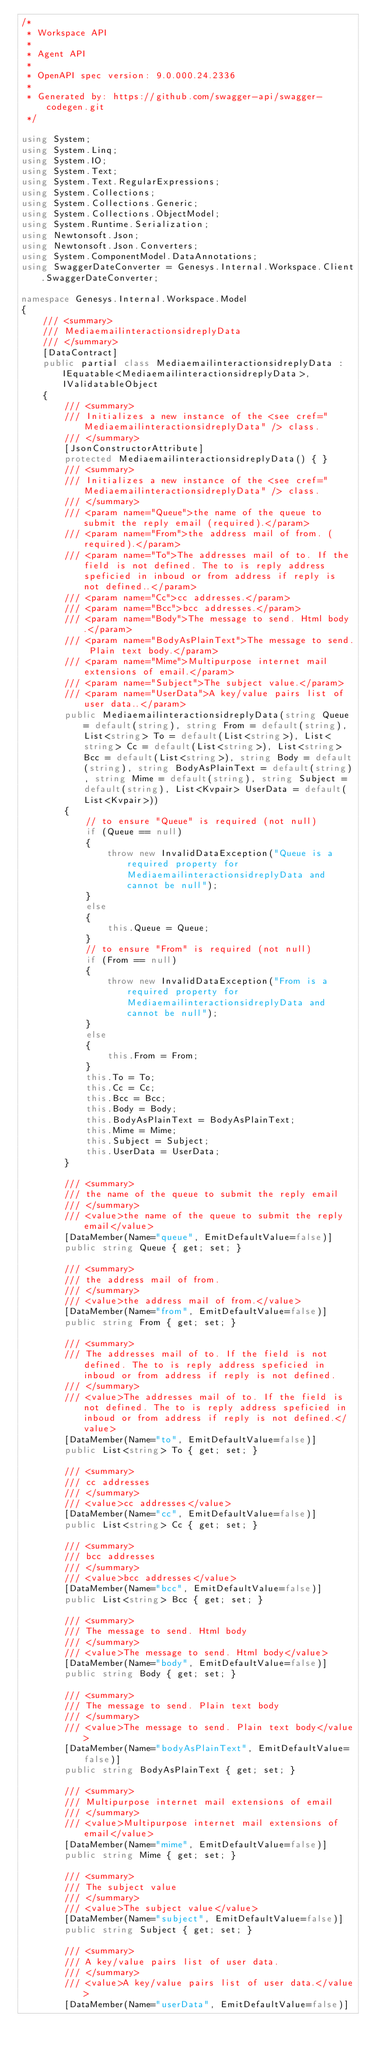Convert code to text. <code><loc_0><loc_0><loc_500><loc_500><_C#_>/* 
 * Workspace API
 *
 * Agent API
 *
 * OpenAPI spec version: 9.0.000.24.2336
 * 
 * Generated by: https://github.com/swagger-api/swagger-codegen.git
 */

using System;
using System.Linq;
using System.IO;
using System.Text;
using System.Text.RegularExpressions;
using System.Collections;
using System.Collections.Generic;
using System.Collections.ObjectModel;
using System.Runtime.Serialization;
using Newtonsoft.Json;
using Newtonsoft.Json.Converters;
using System.ComponentModel.DataAnnotations;
using SwaggerDateConverter = Genesys.Internal.Workspace.Client.SwaggerDateConverter;

namespace Genesys.Internal.Workspace.Model
{
    /// <summary>
    /// MediaemailinteractionsidreplyData
    /// </summary>
    [DataContract]
    public partial class MediaemailinteractionsidreplyData :  IEquatable<MediaemailinteractionsidreplyData>, IValidatableObject
    {
        /// <summary>
        /// Initializes a new instance of the <see cref="MediaemailinteractionsidreplyData" /> class.
        /// </summary>
        [JsonConstructorAttribute]
        protected MediaemailinteractionsidreplyData() { }
        /// <summary>
        /// Initializes a new instance of the <see cref="MediaemailinteractionsidreplyData" /> class.
        /// </summary>
        /// <param name="Queue">the name of the queue to submit the reply email (required).</param>
        /// <param name="From">the address mail of from. (required).</param>
        /// <param name="To">The addresses mail of to. If the field is not defined. The to is reply address speficied in inboud or from address if reply is not defined..</param>
        /// <param name="Cc">cc addresses.</param>
        /// <param name="Bcc">bcc addresses.</param>
        /// <param name="Body">The message to send. Html body.</param>
        /// <param name="BodyAsPlainText">The message to send. Plain text body.</param>
        /// <param name="Mime">Multipurpose internet mail extensions of email.</param>
        /// <param name="Subject">The subject value.</param>
        /// <param name="UserData">A key/value pairs list of user data..</param>
        public MediaemailinteractionsidreplyData(string Queue = default(string), string From = default(string), List<string> To = default(List<string>), List<string> Cc = default(List<string>), List<string> Bcc = default(List<string>), string Body = default(string), string BodyAsPlainText = default(string), string Mime = default(string), string Subject = default(string), List<Kvpair> UserData = default(List<Kvpair>))
        {
            // to ensure "Queue" is required (not null)
            if (Queue == null)
            {
                throw new InvalidDataException("Queue is a required property for MediaemailinteractionsidreplyData and cannot be null");
            }
            else
            {
                this.Queue = Queue;
            }
            // to ensure "From" is required (not null)
            if (From == null)
            {
                throw new InvalidDataException("From is a required property for MediaemailinteractionsidreplyData and cannot be null");
            }
            else
            {
                this.From = From;
            }
            this.To = To;
            this.Cc = Cc;
            this.Bcc = Bcc;
            this.Body = Body;
            this.BodyAsPlainText = BodyAsPlainText;
            this.Mime = Mime;
            this.Subject = Subject;
            this.UserData = UserData;
        }
        
        /// <summary>
        /// the name of the queue to submit the reply email
        /// </summary>
        /// <value>the name of the queue to submit the reply email</value>
        [DataMember(Name="queue", EmitDefaultValue=false)]
        public string Queue { get; set; }

        /// <summary>
        /// the address mail of from.
        /// </summary>
        /// <value>the address mail of from.</value>
        [DataMember(Name="from", EmitDefaultValue=false)]
        public string From { get; set; }

        /// <summary>
        /// The addresses mail of to. If the field is not defined. The to is reply address speficied in inboud or from address if reply is not defined.
        /// </summary>
        /// <value>The addresses mail of to. If the field is not defined. The to is reply address speficied in inboud or from address if reply is not defined.</value>
        [DataMember(Name="to", EmitDefaultValue=false)]
        public List<string> To { get; set; }

        /// <summary>
        /// cc addresses
        /// </summary>
        /// <value>cc addresses</value>
        [DataMember(Name="cc", EmitDefaultValue=false)]
        public List<string> Cc { get; set; }

        /// <summary>
        /// bcc addresses
        /// </summary>
        /// <value>bcc addresses</value>
        [DataMember(Name="bcc", EmitDefaultValue=false)]
        public List<string> Bcc { get; set; }

        /// <summary>
        /// The message to send. Html body
        /// </summary>
        /// <value>The message to send. Html body</value>
        [DataMember(Name="body", EmitDefaultValue=false)]
        public string Body { get; set; }

        /// <summary>
        /// The message to send. Plain text body
        /// </summary>
        /// <value>The message to send. Plain text body</value>
        [DataMember(Name="bodyAsPlainText", EmitDefaultValue=false)]
        public string BodyAsPlainText { get; set; }

        /// <summary>
        /// Multipurpose internet mail extensions of email
        /// </summary>
        /// <value>Multipurpose internet mail extensions of email</value>
        [DataMember(Name="mime", EmitDefaultValue=false)]
        public string Mime { get; set; }

        /// <summary>
        /// The subject value
        /// </summary>
        /// <value>The subject value</value>
        [DataMember(Name="subject", EmitDefaultValue=false)]
        public string Subject { get; set; }

        /// <summary>
        /// A key/value pairs list of user data.
        /// </summary>
        /// <value>A key/value pairs list of user data.</value>
        [DataMember(Name="userData", EmitDefaultValue=false)]</code> 